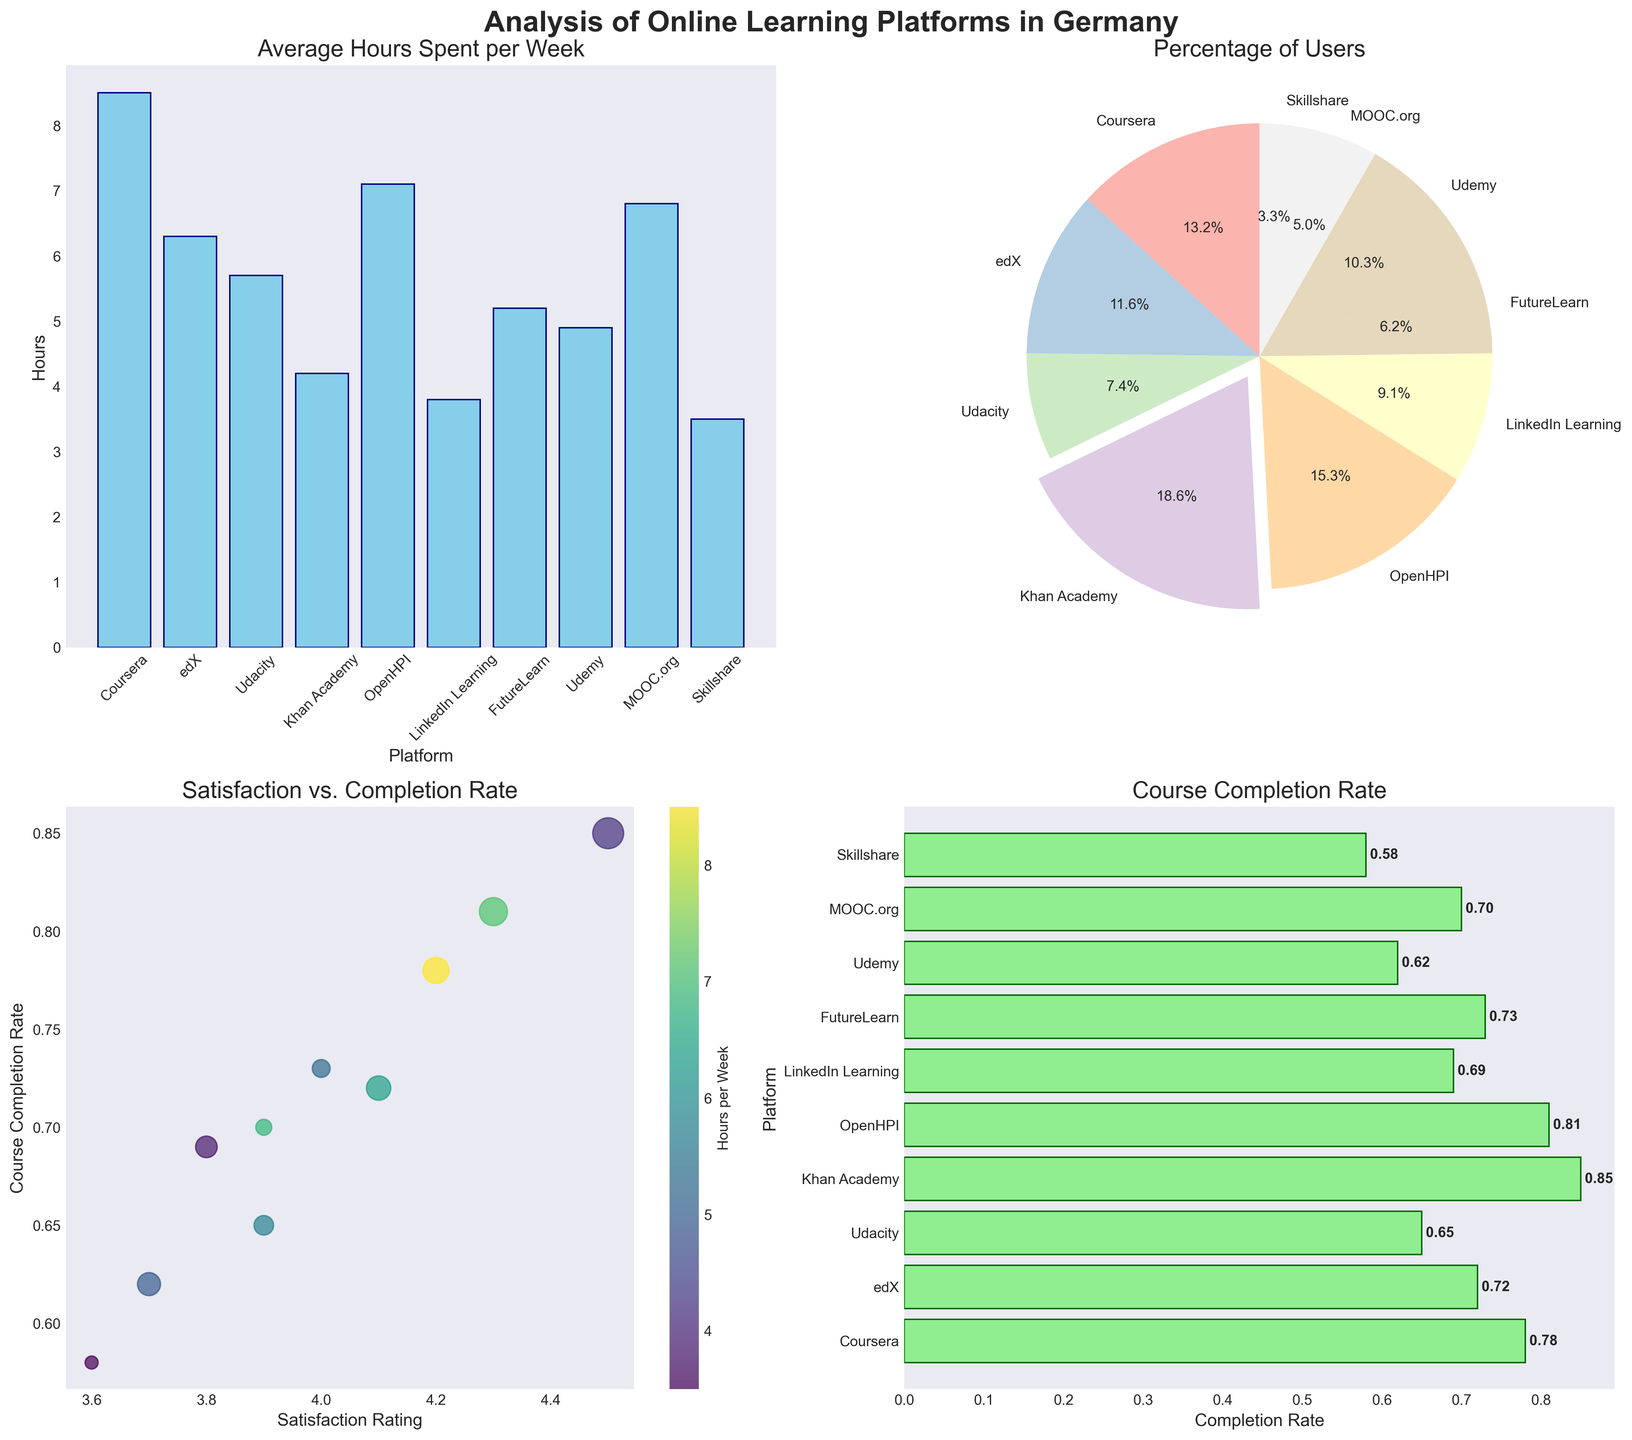what is the title of the first subplot? The title of a subplot is usually displayed at the top of the subplot. For the first subplot, it can be found written in a larger font size and reads as 'Average Hours Spent per Week'.
Answer: Average Hours Spent per Week Which platform has the highest course completion rate? To determine the platform with the highest course completion rate, we need to look at the horizontal bar chart in the fourth subplot and identify the longest bar. In this case, 'Khan Academy' has the highest completion rate of around 0.85.
Answer: Khan Academy What is the percentage of users for the platform with the most users? Looking at the pie chart in the second subplot, the largest segment, which is slightly exploded, corresponds to 'Khan Academy'. The percentage shown on this segment is 45.0%.
Answer: 45.0% Which platform has the highest satisfaction rating and what is its course completion rate? In the scatter plot (third subplot), locate the point with the highest value on the x-axis representing the satisfaction rating. 'Khan Academy' has the highest satisfaction rating of 4.5. The corresponding y-axis value for completion rate is 0.85.
Answer: Khan Academy, 0.85 What is the difference in average hours spent per week between Coursera and LinkedIn Learning? From the bar chart (first subplot), note the values for Coursera and LinkedIn Learning: Coursera is 8.5 hours, and LinkedIn Learning is 3.8 hours. The difference is calculated as 8.5 - 3.8.
Answer: 4.7 Which platform has the lowest satisfaction rating and what percentage of users does it have? The scatter plot shows satisfaction ratings. The lowest satisfaction rating value falls to 'Skillshare' (3.6). The pie chart shows that Skillshare holds 8% of users.
Answer: Skillshare, 8% Is there any platform where the course completion rate is above 0.8 but the user percentage is below 20%? Check the horizontal bar chart for platforms with completion rates above 0.8 (bars extending past 0.8). Then verify user percentages for these in the pie chart. 'OpenHPI' (completion rate 0.81) has a user percentage not listed below 20%.
Answer: No Which platform has a higher course completion rate: Udemy or FutureLearn? From the horizontal bar chart, compare the lengths of the bars for 'Udemy' and 'FutureLearn'. 'FutureLearn' has a higher course completion rate (0.73) than 'Udemy' (0.62).
Answer: FutureLearn What average number of hours per week do students spend on Khan Academy and edX combined? Refer to the bar chart to find hours per week: Khan Academy (4.2) and edX (6.3). The sum is 4.2 + 6.3. The average is calculated as (4.2 + 6.3) / 2.
Answer: 5.25 